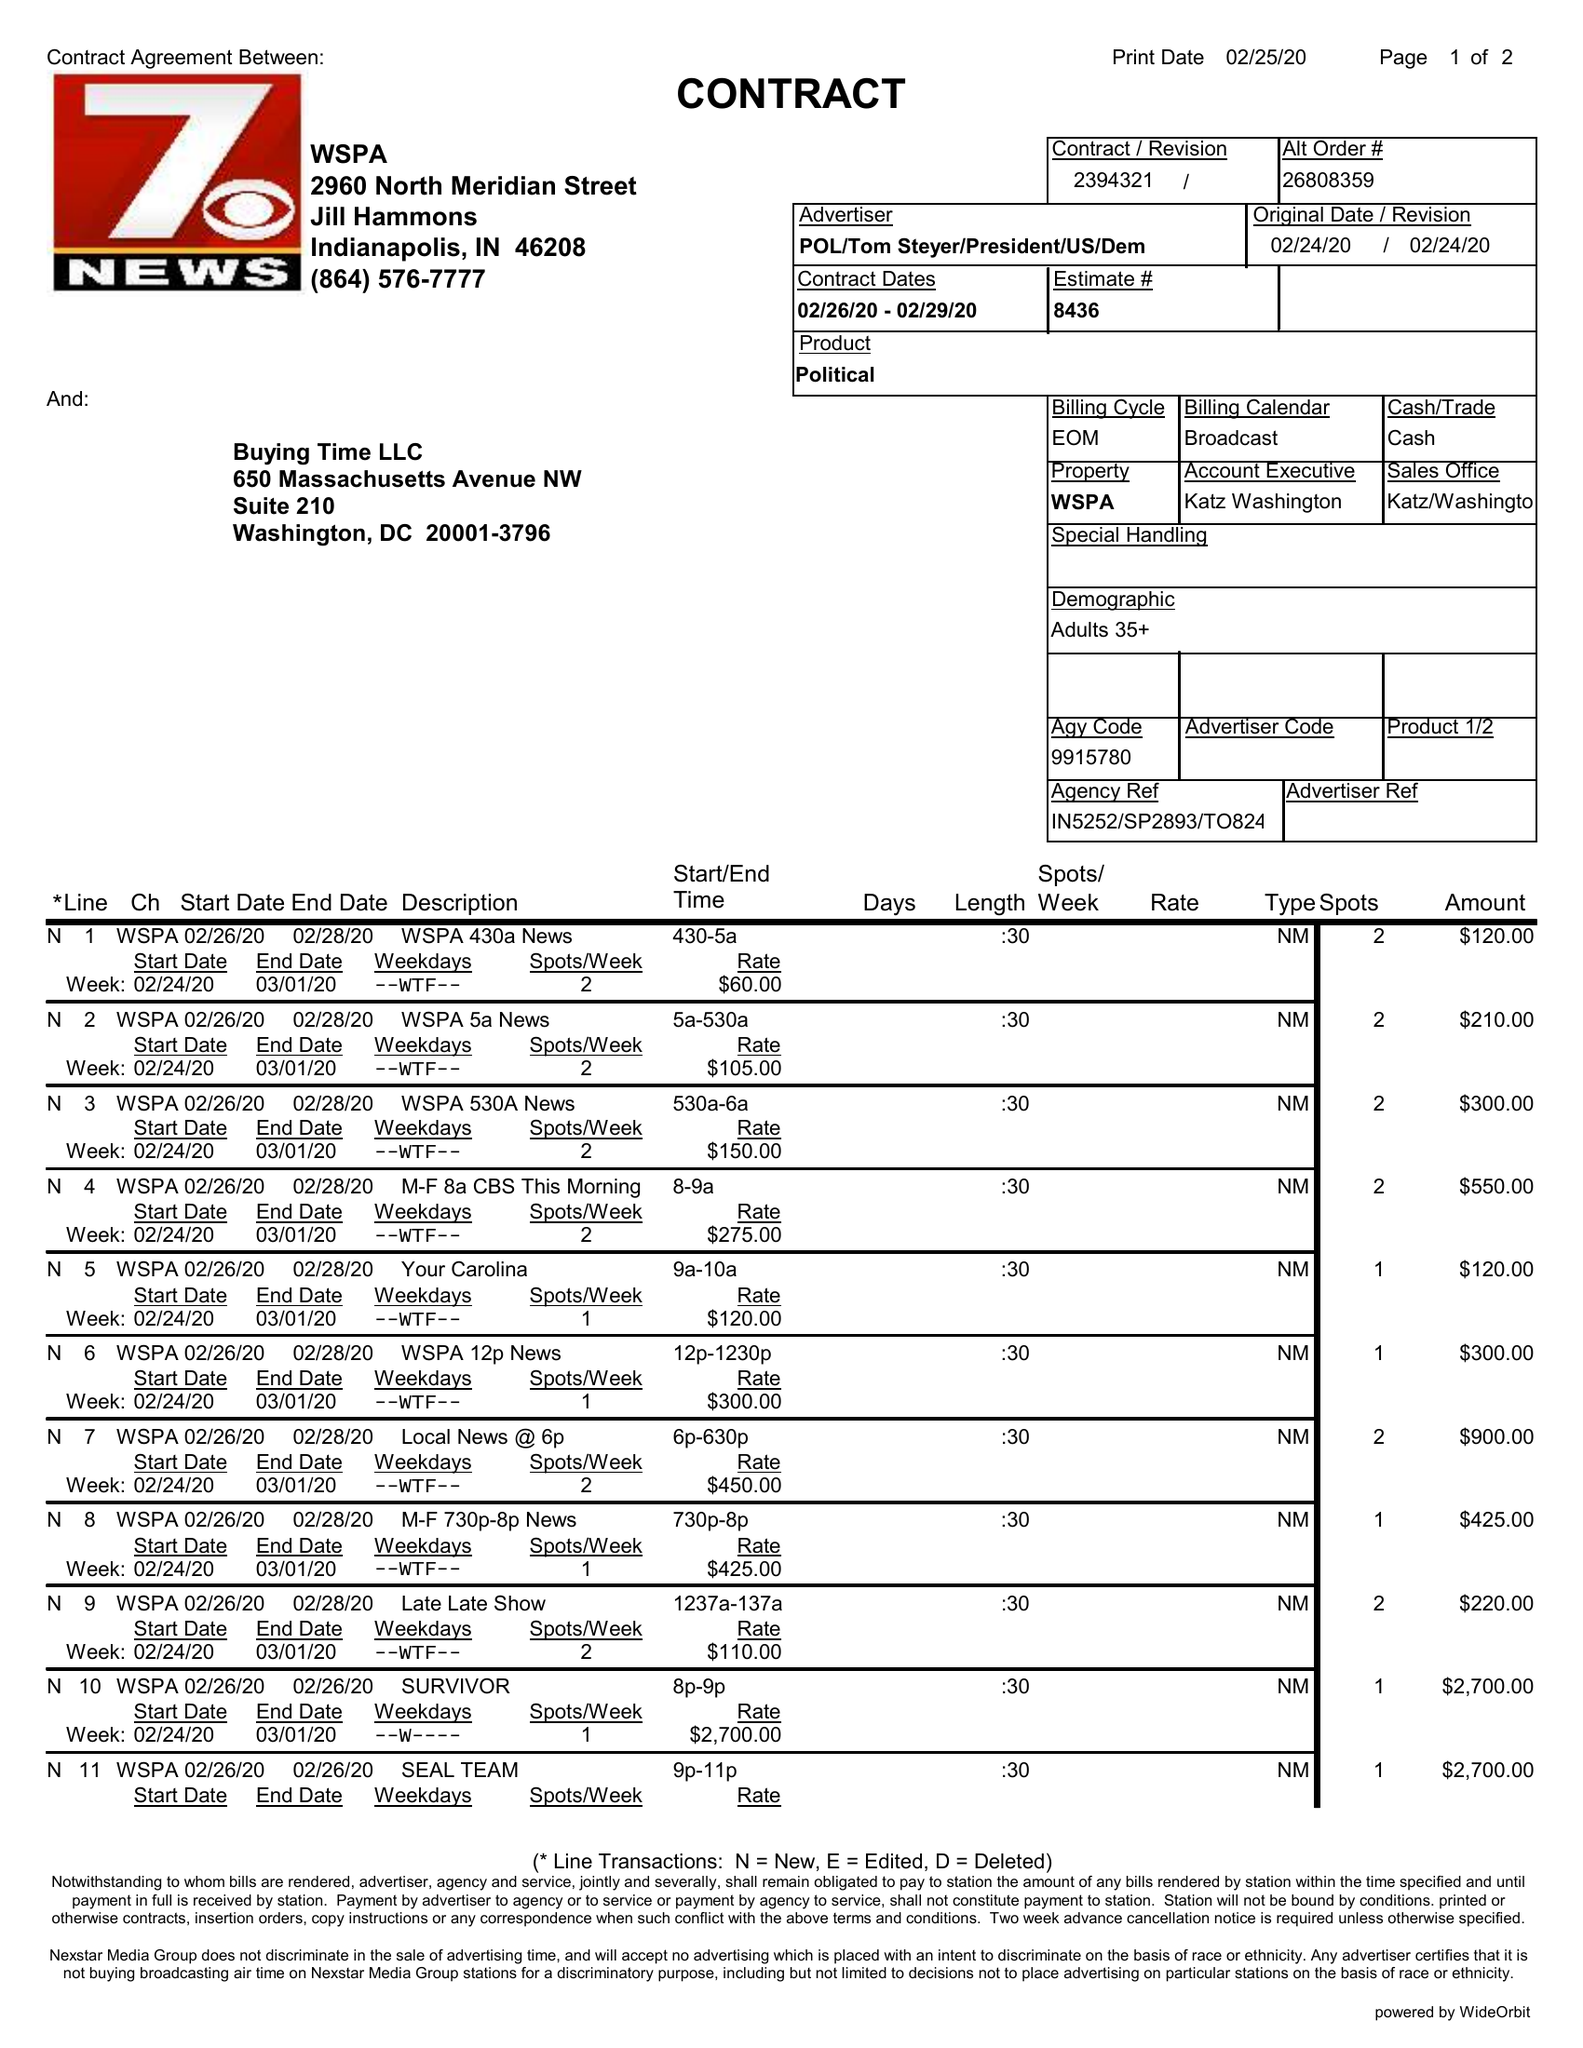What is the value for the flight_from?
Answer the question using a single word or phrase. 02/26/20 